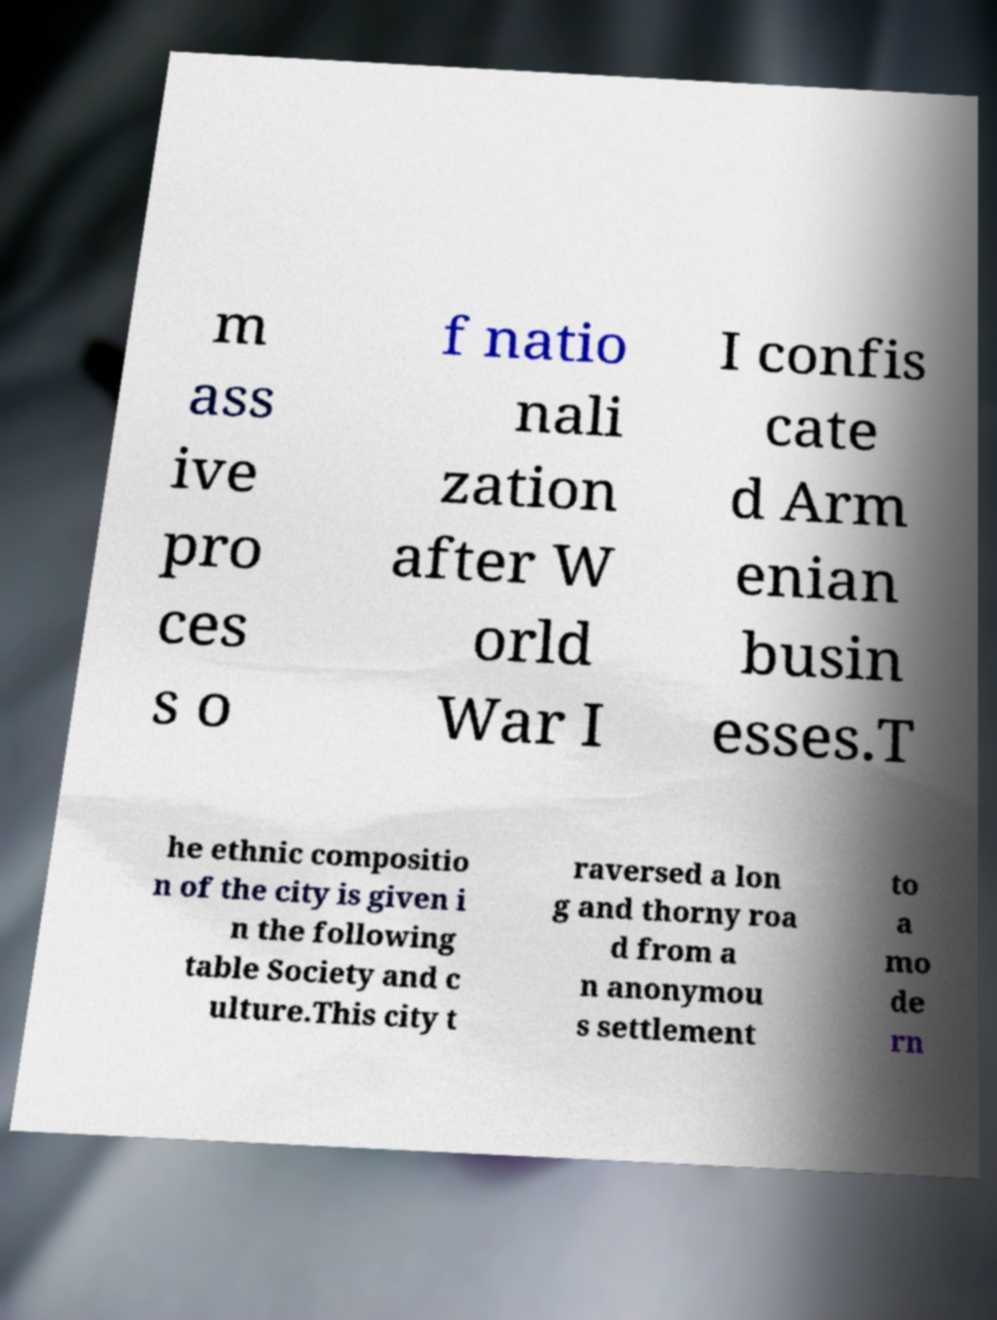I need the written content from this picture converted into text. Can you do that? m ass ive pro ces s o f natio nali zation after W orld War I I confis cate d Arm enian busin esses.T he ethnic compositio n of the city is given i n the following table Society and c ulture.This city t raversed a lon g and thorny roa d from a n anonymou s settlement to a mo de rn 